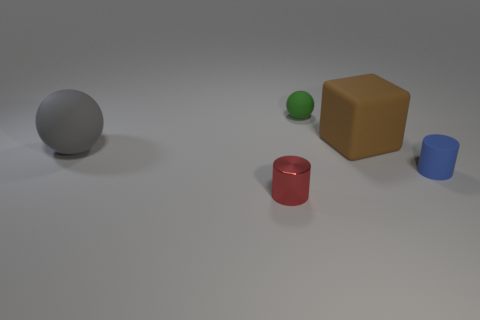How might the lighting in this scene suggest a time of day or specific mood? The soft, diffuse lighting in the scene, with no harsh shadows or bright highlights, suggests an overcast day or artificial lighting from an interior setting. It creates a neutral to slightly solemn mood, lacking the warmth or drama typical of early morning or late afternoon sunlight. 